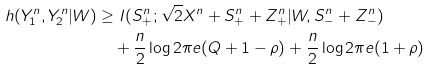<formula> <loc_0><loc_0><loc_500><loc_500>h ( Y _ { 1 } ^ { n } , Y _ { 2 } ^ { n } | W ) & \geq I ( S _ { + } ^ { n } ; \sqrt { 2 } X ^ { n } + S _ { + } ^ { n } + Z _ { + } ^ { n } | W , S _ { - } ^ { n } + Z _ { - } ^ { n } ) \\ & \quad + \frac { n } { 2 } \log 2 \pi e ( Q + 1 - \rho ) + \frac { n } { 2 } \log 2 \pi e ( 1 + \rho )</formula> 